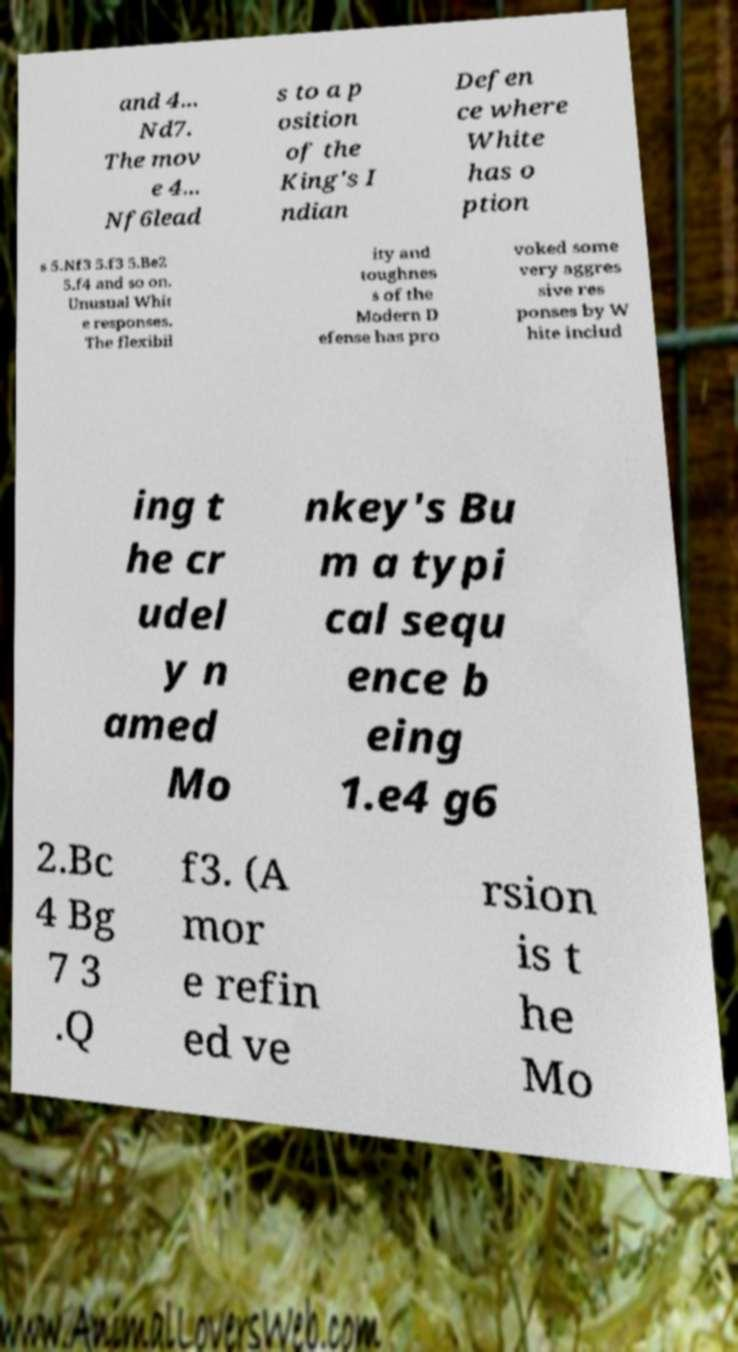There's text embedded in this image that I need extracted. Can you transcribe it verbatim? and 4... Nd7. The mov e 4... Nf6lead s to a p osition of the King's I ndian Defen ce where White has o ption s 5.Nf3 5.f3 5.Be2 5.f4 and so on. Unusual Whit e responses. The flexibil ity and toughnes s of the Modern D efense has pro voked some very aggres sive res ponses by W hite includ ing t he cr udel y n amed Mo nkey's Bu m a typi cal sequ ence b eing 1.e4 g6 2.Bc 4 Bg 7 3 .Q f3. (A mor e refin ed ve rsion is t he Mo 